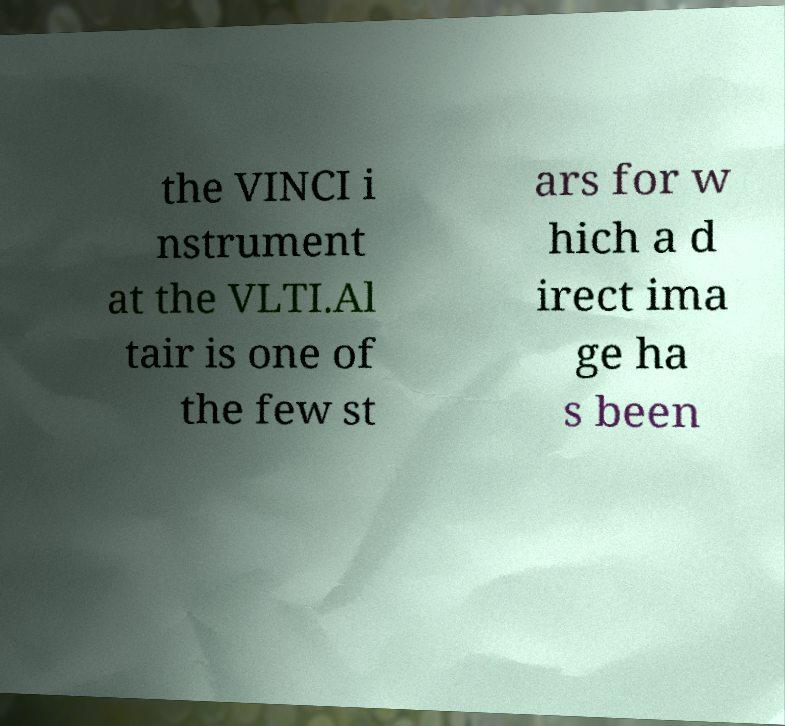Please identify and transcribe the text found in this image. the VINCI i nstrument at the VLTI.Al tair is one of the few st ars for w hich a d irect ima ge ha s been 